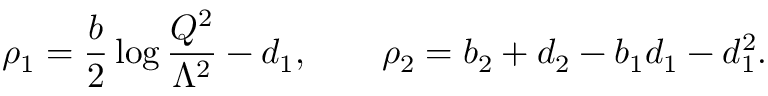<formula> <loc_0><loc_0><loc_500><loc_500>\rho _ { 1 } = \frac { b } { 2 } \log \frac { Q ^ { 2 } } { \Lambda ^ { 2 } } - d _ { 1 } , \quad \rho _ { 2 } = b _ { 2 } + d _ { 2 } - b _ { 1 } d _ { 1 } - d _ { 1 } ^ { 2 } .</formula> 